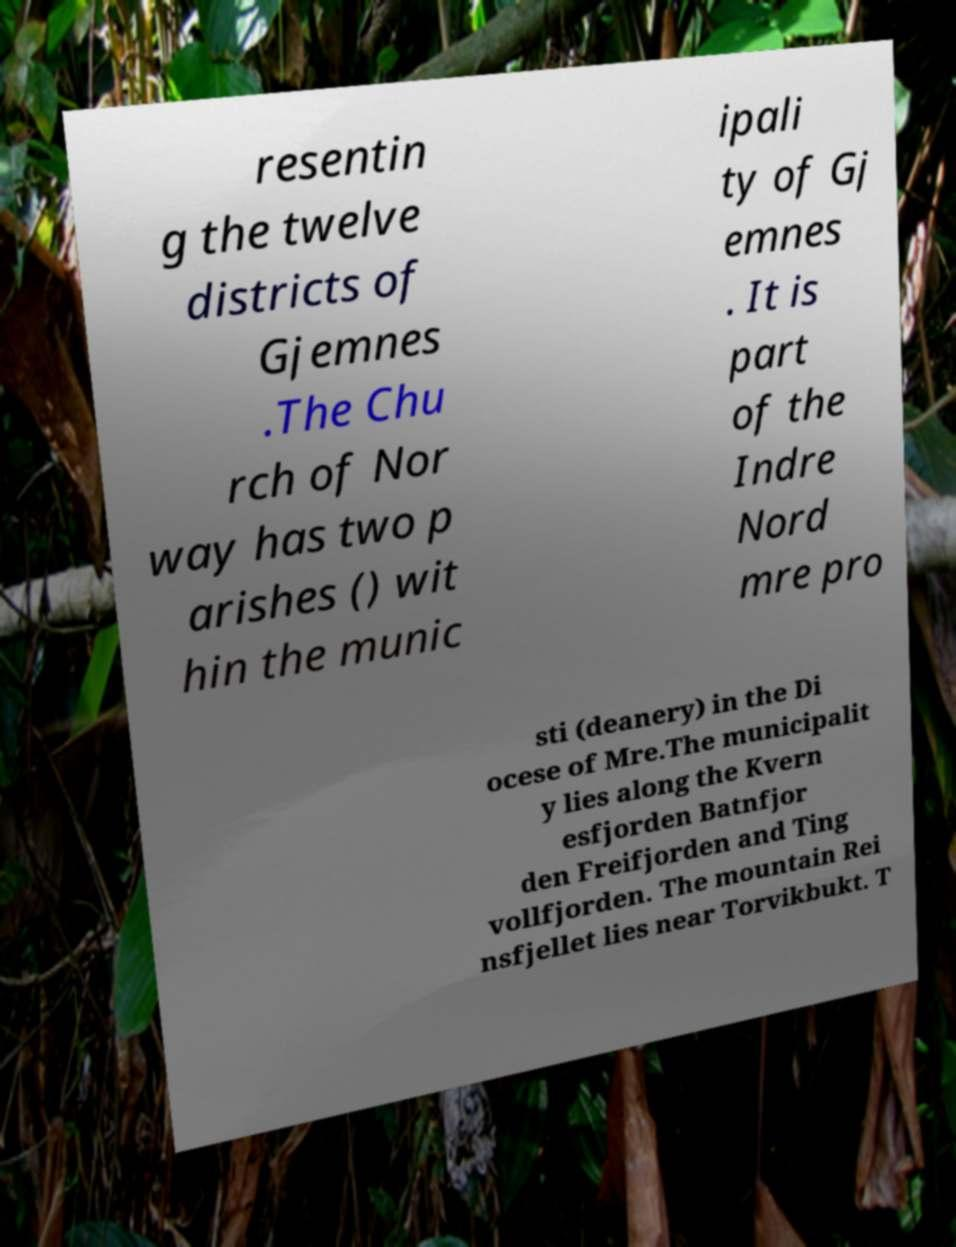Can you accurately transcribe the text from the provided image for me? resentin g the twelve districts of Gjemnes .The Chu rch of Nor way has two p arishes () wit hin the munic ipali ty of Gj emnes . It is part of the Indre Nord mre pro sti (deanery) in the Di ocese of Mre.The municipalit y lies along the Kvern esfjorden Batnfjor den Freifjorden and Ting vollfjorden. The mountain Rei nsfjellet lies near Torvikbukt. T 